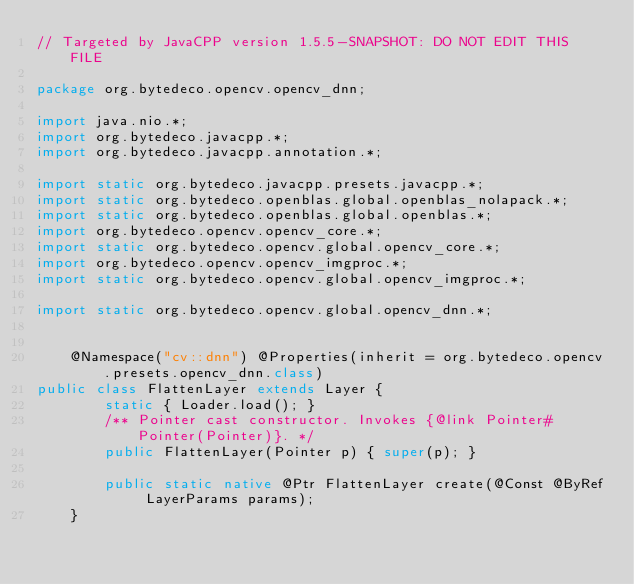<code> <loc_0><loc_0><loc_500><loc_500><_Java_>// Targeted by JavaCPP version 1.5.5-SNAPSHOT: DO NOT EDIT THIS FILE

package org.bytedeco.opencv.opencv_dnn;

import java.nio.*;
import org.bytedeco.javacpp.*;
import org.bytedeco.javacpp.annotation.*;

import static org.bytedeco.javacpp.presets.javacpp.*;
import static org.bytedeco.openblas.global.openblas_nolapack.*;
import static org.bytedeco.openblas.global.openblas.*;
import org.bytedeco.opencv.opencv_core.*;
import static org.bytedeco.opencv.global.opencv_core.*;
import org.bytedeco.opencv.opencv_imgproc.*;
import static org.bytedeco.opencv.global.opencv_imgproc.*;

import static org.bytedeco.opencv.global.opencv_dnn.*;


    @Namespace("cv::dnn") @Properties(inherit = org.bytedeco.opencv.presets.opencv_dnn.class)
public class FlattenLayer extends Layer {
        static { Loader.load(); }
        /** Pointer cast constructor. Invokes {@link Pointer#Pointer(Pointer)}. */
        public FlattenLayer(Pointer p) { super(p); }
    
        public static native @Ptr FlattenLayer create(@Const @ByRef LayerParams params);
    }
</code> 